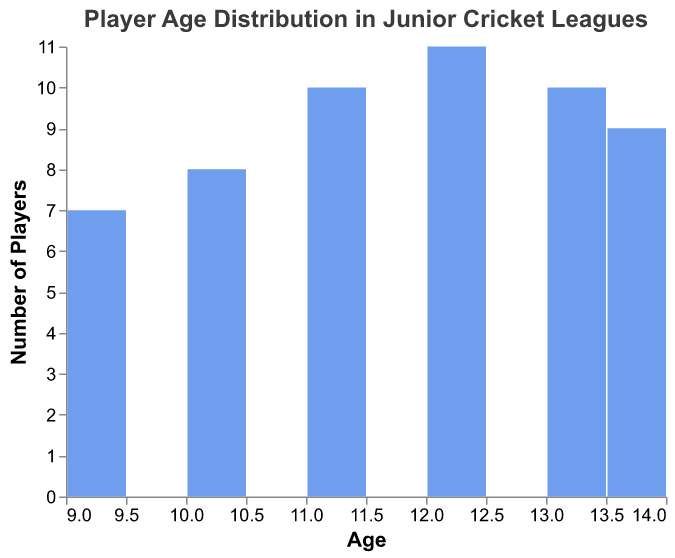What is the title of the plot? The title is often found at the top of the plot, describing what the plot is about. In this case, the title given in the code is "Player Age Distribution in Junior Cricket Leagues".
Answer: Player Age Distribution in Junior Cricket Leagues What range of ages is shown on the x-axis? The x-axis typically represents the range of values for the plot's primary variable. Here, it shows the age of players, which ranges from 9 to 14 years old.
Answer: 9 to 14 Which age group has the highest number of players? Look at the y-axis, which shows the number of players. The bar that reaches the highest on this axis will indicate the age group with the highest number of players. The age group with the most players has the tallest bar at age 12.
Answer: 12 How many players are there in the age group of 11? Find the bar corresponding to the age group of 11 on the x-axis, and then see where it reaches on the y-axis to determine the number of players.
Answer: 10 How many more players are there in the age group of 11 than in the age group of 9? First, identify the number of players in both the age groups, then subtract the number of players in the age group of 9 from the number of players in the age group of 11. Age 11 has 10 players, and age 9 has 7 players. 10 - 7 = 3.
Answer: 3 What percentage of players are aged 14? Sum the number of players across all age groups to find the total. Then, divide the number of 14-year-old players by this total and multiply by 100 to get the percentage. There are a total of 55 players, and 14-year-olds make up 9. (9/55)*100 = 16.36%.
Answer: 16.36% Are there more players aged 10 or aged 13? Compare the heights of the bars corresponding to ages 10 and 13. The taller bar will indicate the age group with more players. Age 13 has 10 players, and age 10 has 8 players.
Answer: Age 13 What is the total number of players in the league? Sum the counts of players across all age groups as shown by the y-axis. Add up the individual counts from all the bars. The total is 55.
Answer: 55 Which age groups have exactly 10 players? Identify the bars on the plot that reach exactly up to 10 on the y-axis. The age groups for these bars are 11 and 13.
Answer: 11 and 13 